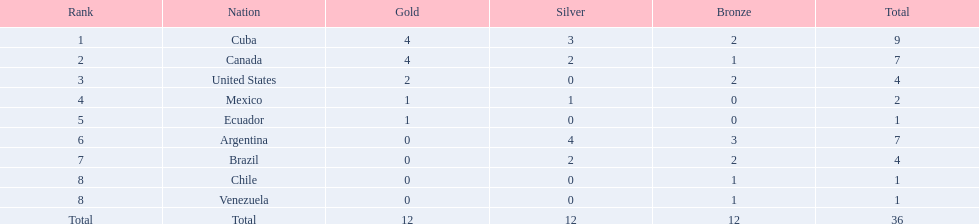What countries were involved? Cuba, 4, 3, 2, Canada, 4, 2, 1, United States, 2, 0, 2, Mexico, 1, 1, 0, Ecuador, 1, 0, 0, Argentina, 0, 4, 3, Brazil, 0, 2, 2, Chile, 0, 0, 1, Venezuela, 0, 0, 1. What countries achieved 1 gold? Mexico, 1, 1, 0, Ecuador, 1, 0, 0. What country mentioned also gained no silver? Ecuador. 